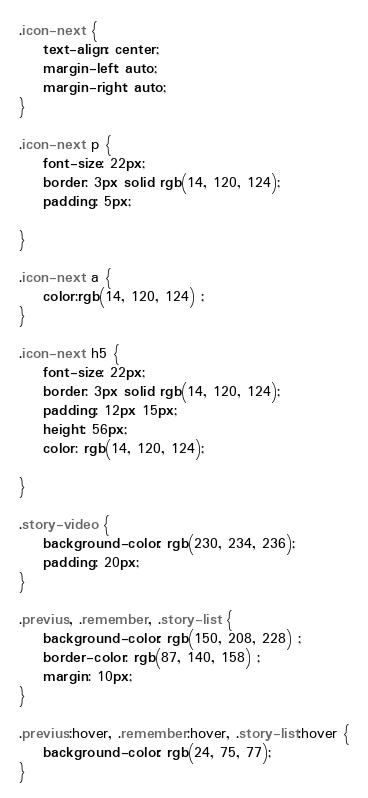Convert code to text. <code><loc_0><loc_0><loc_500><loc_500><_CSS_>.icon-next {
    text-align: center;
    margin-left: auto;
    margin-right: auto;
}

.icon-next p {
    font-size: 22px;
    border: 3px solid rgb(14, 120, 124);
    padding: 5px;

}

.icon-next a {
    color:rgb(14, 120, 124) ;
}

.icon-next h5 {
    font-size: 22px;
    border: 3px solid rgb(14, 120, 124);
    padding: 12px 15px;
    height: 56px;
    color: rgb(14, 120, 124);

}

.story-video {
    background-color: rgb(230, 234, 236);
    padding: 20px;
}

.previus, .remember, .story-list {
    background-color: rgb(150, 208, 228) ;
    border-color: rgb(87, 140, 158) ;
    margin: 10px;
}

.previus:hover, .remember:hover, .story-list:hover {
    background-color: rgb(24, 75, 77);
}


</code> 